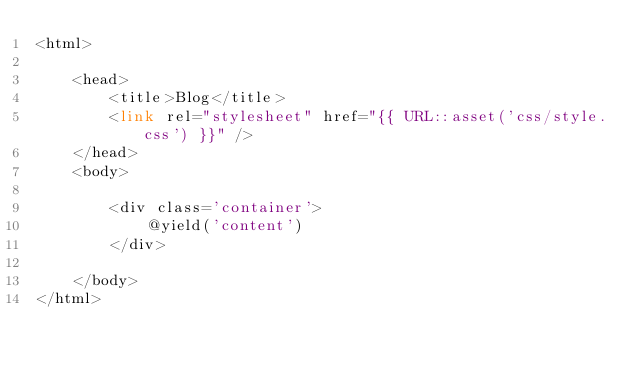Convert code to text. <code><loc_0><loc_0><loc_500><loc_500><_PHP_><html>
    
    <head>
        <title>Blog</title>
        <link rel="stylesheet" href="{{ URL::asset('css/style.css') }}" />
    </head>
    <body>
        
        <div class='container'>
            @yield('content')
        </div> 
        
    </body>
</html>
</code> 